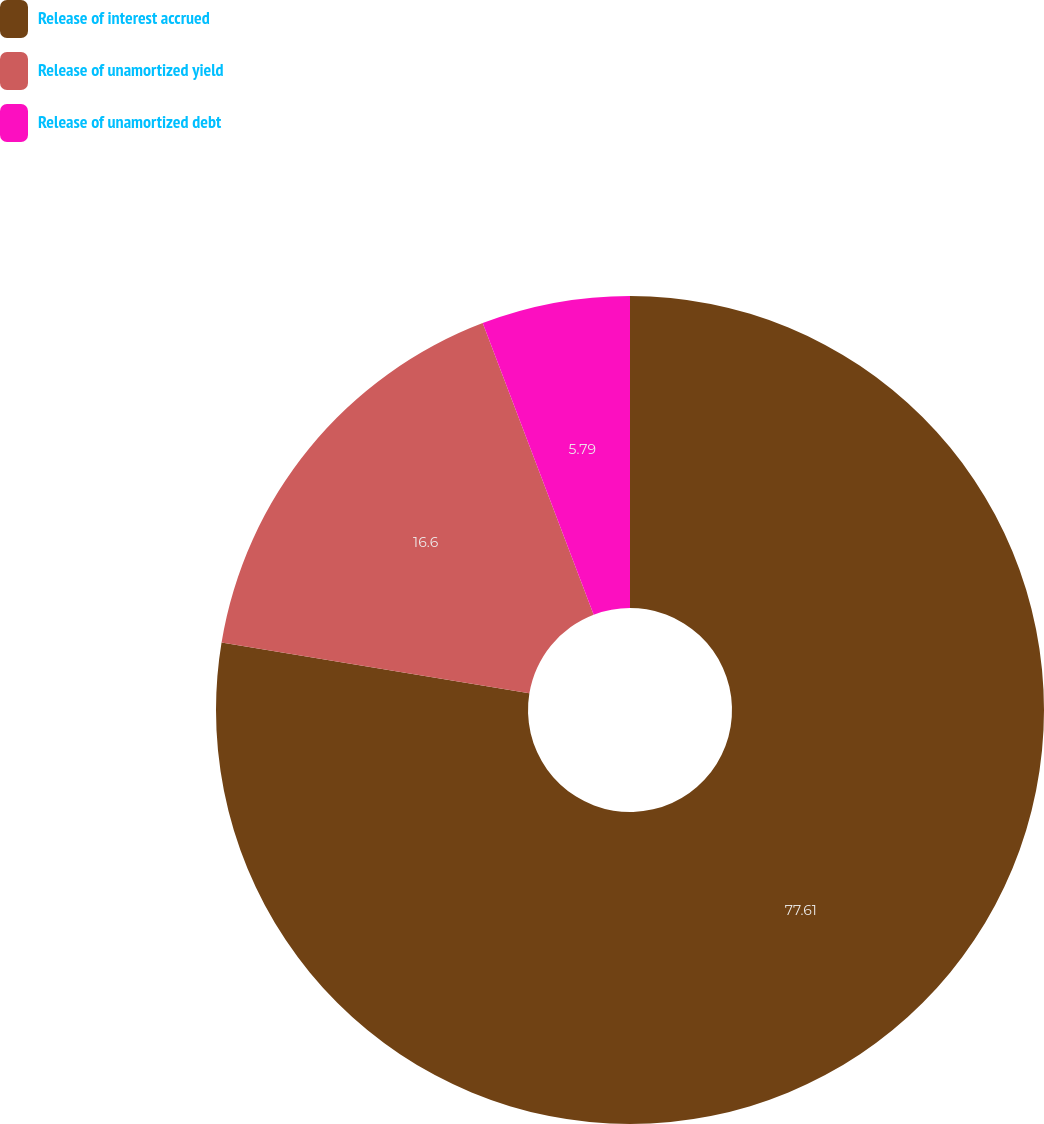Convert chart. <chart><loc_0><loc_0><loc_500><loc_500><pie_chart><fcel>Release of interest accrued<fcel>Release of unamortized yield<fcel>Release of unamortized debt<nl><fcel>77.61%<fcel>16.6%<fcel>5.79%<nl></chart> 